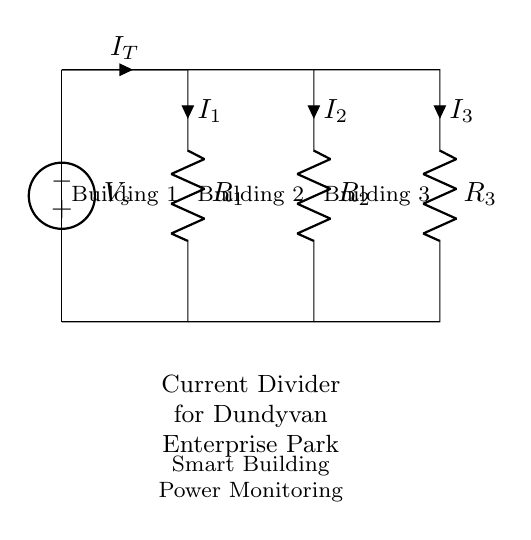What is the total current entering the circuit? The total current entering the circuit is represented as I_T, which flows into the parallel branches at the top of the circuit diagram.
Answer: I_T What are the resistor values in this circuit? The circuit diagram specifies three resistors labeled as R_1, R_2, and R_3; however, their specific numerical values are not shown in the diagram itself.
Answer: Not specified Which building has the largest current? The building with the largest current corresponds to the smallest resistor due to the current divider rule, but without specific resistance values or currents, the answer cannot be determined from the diagram alone.
Answer: Cannot determine How does the current divide in this circuit? The current divides among the three resistors according to their resistance values: smaller resistance receives a larger current. The formula for current division in parallel circuits is used to calculate this distribution.
Answer: According to resistance values What does R_1 represent? R_1 represents the resistance associated with Building 1, as labeled in the diagram.
Answer: Building 1 What is the purpose of the current divider in the Dundyvan Enterprise Park? The purpose of the current divider is to monitor power consumption by distributing the total current across different smart buildings, allowing individual measurement of power used by each.
Answer: Power consumption monitoring 